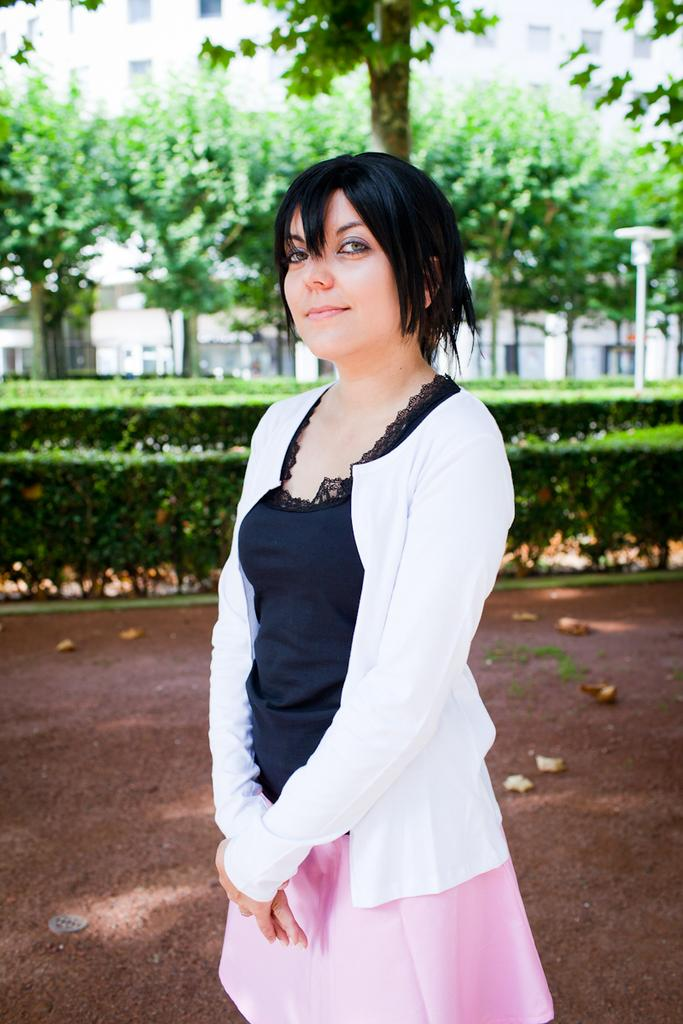Who is the main subject in the foreground of the image? There is a woman in the foreground of the image. What is the woman wearing in the image? The woman is wearing a skirt and a white shirt in the image. What can be seen in the background of the image? Land, plants, trees, and a building are visible in the background of the image. Can you describe the pole on the right side of the image? There is a pole on the right side of the image. What story is the woman telling her daughter in the image? There is no indication in the image that the woman is telling a story or has a daughter present. How many spiders are visible on the woman's skirt in the image? There are no spiders visible on the woman's skirt in the image. 